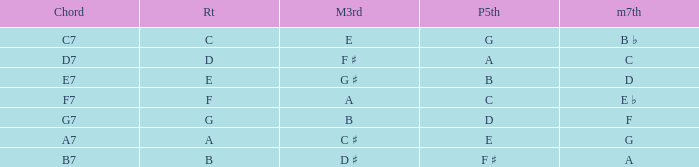What is the Chord with a Minor that is seventh of f? G7. 